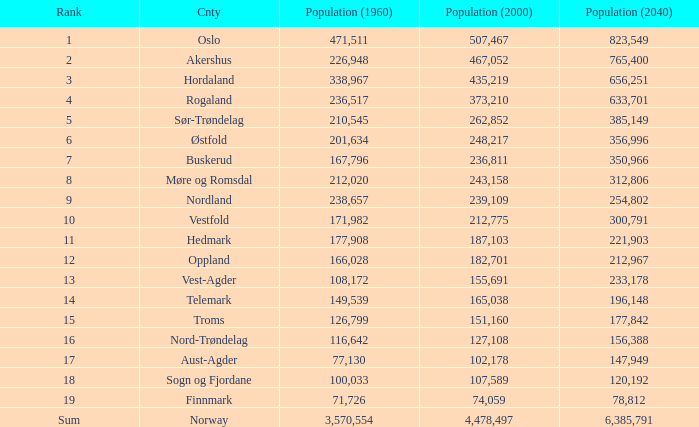What was Oslo's population in 1960, with a population of 507,467 in 2000? None. 